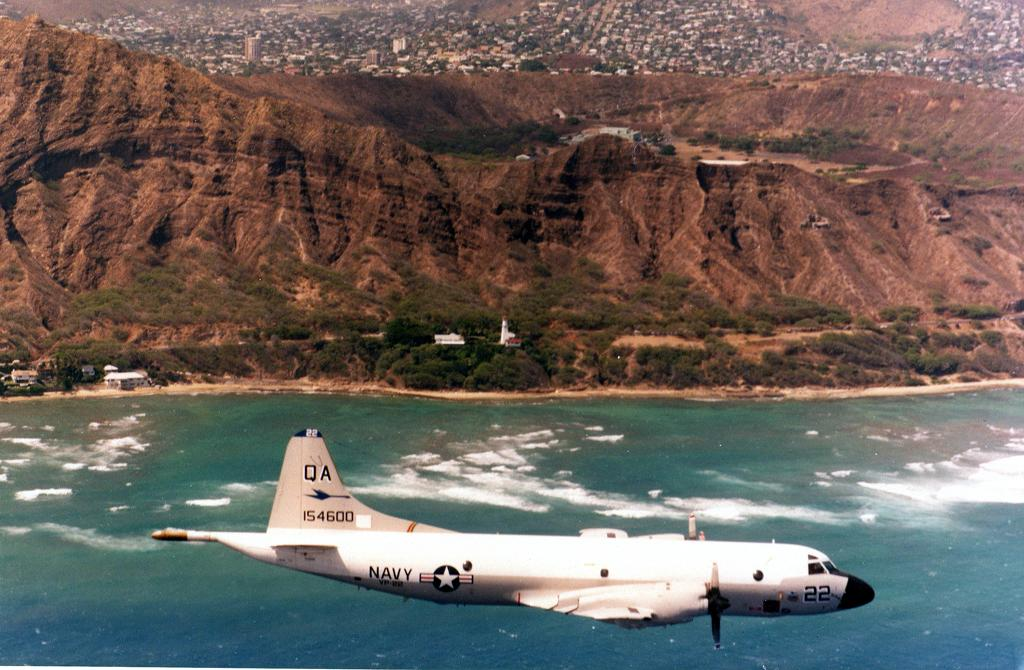<image>
Give a short and clear explanation of the subsequent image. a plane owned by the Navy flying over the ocean 